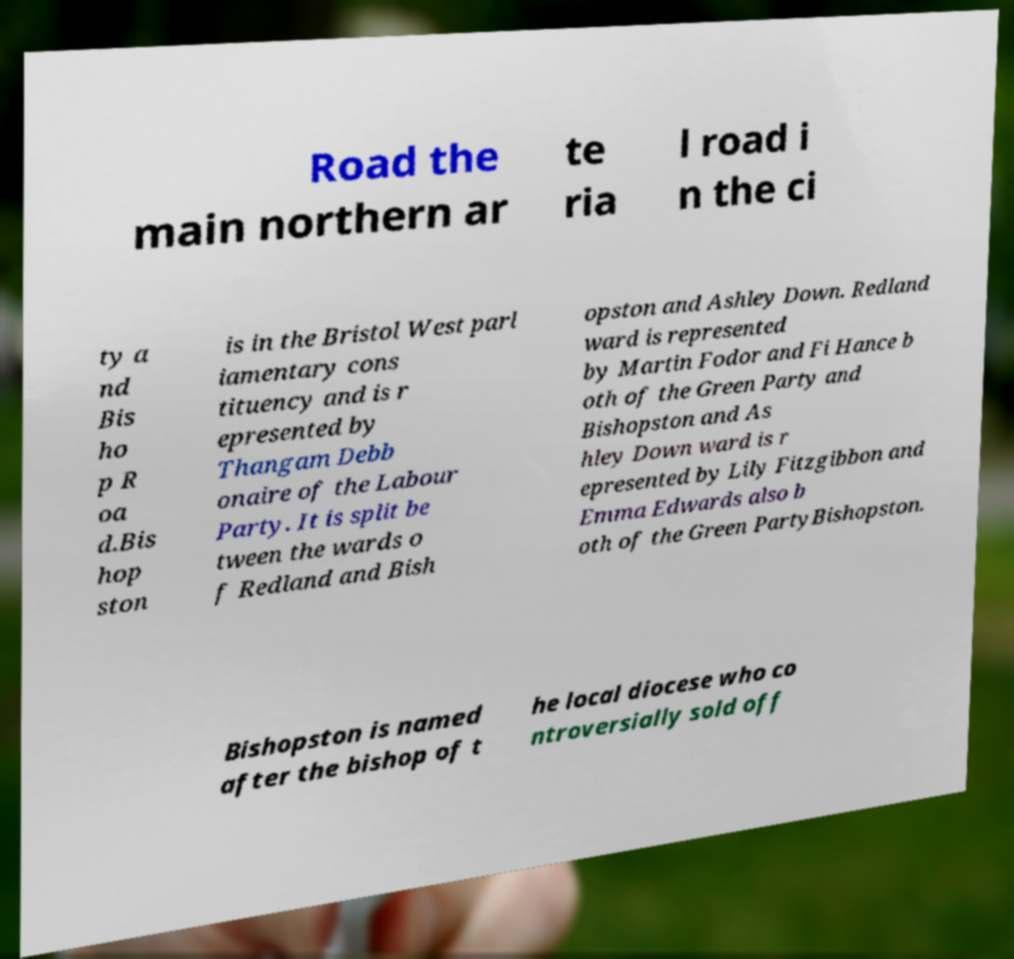Can you accurately transcribe the text from the provided image for me? Road the main northern ar te ria l road i n the ci ty a nd Bis ho p R oa d.Bis hop ston is in the Bristol West parl iamentary cons tituency and is r epresented by Thangam Debb onaire of the Labour Party. It is split be tween the wards o f Redland and Bish opston and Ashley Down. Redland ward is represented by Martin Fodor and Fi Hance b oth of the Green Party and Bishopston and As hley Down ward is r epresented by Lily Fitzgibbon and Emma Edwards also b oth of the Green PartyBishopston. Bishopston is named after the bishop of t he local diocese who co ntroversially sold off 